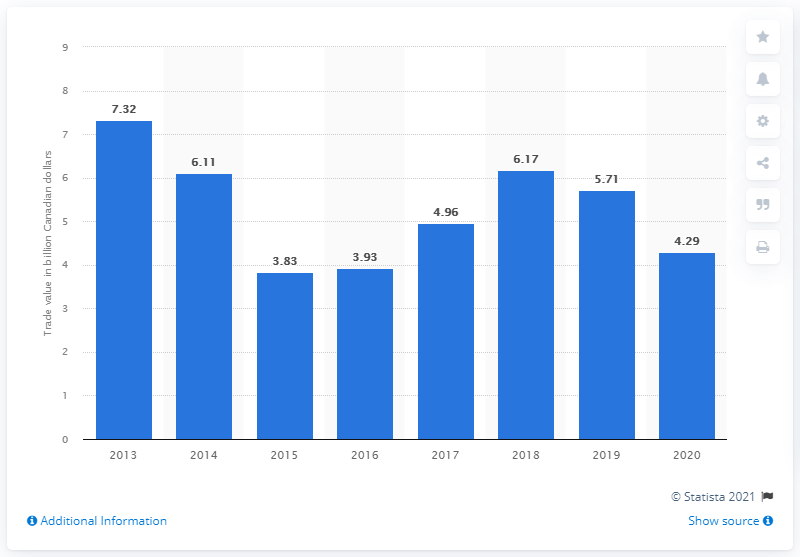Draw attention to some important aspects in this diagram. In 2010, the value of imports from the Middle East to Canada was 5.71 billion dollars. In 2020, the value of imports from the Middle East to Canada was 4.29 billion US dollars. 